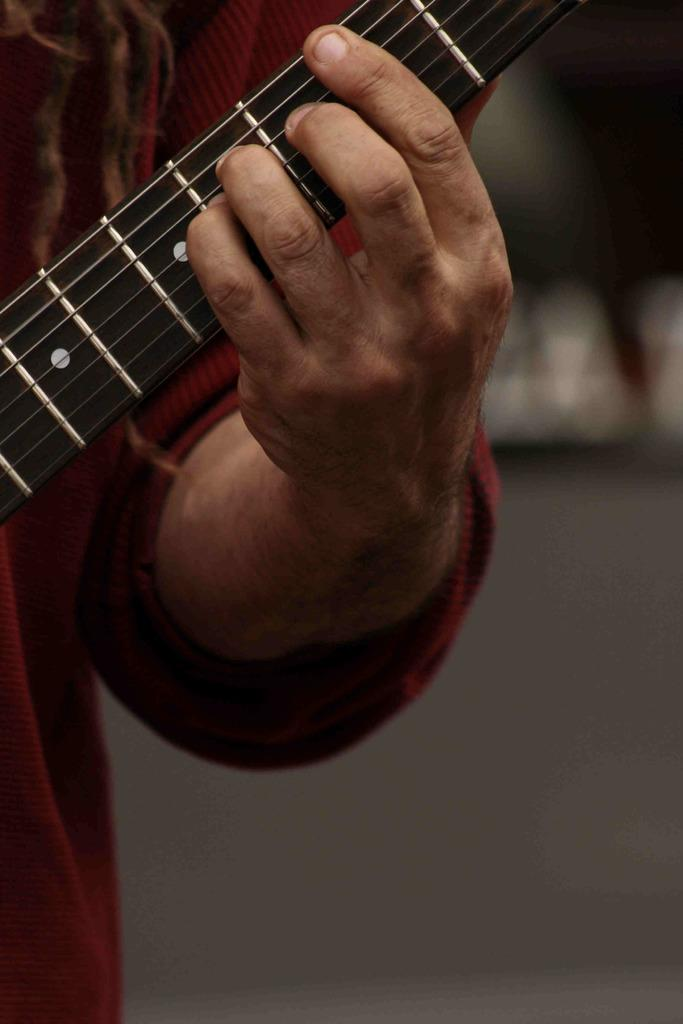Who is present in the image? There is a person in the image. What is the person holding in the image? The person is holding a guitar. What is the person doing with the guitar? The person's fingers are placed on the strings of the guitar. What type of pies can be seen in the image? There are no pies present in the image. 